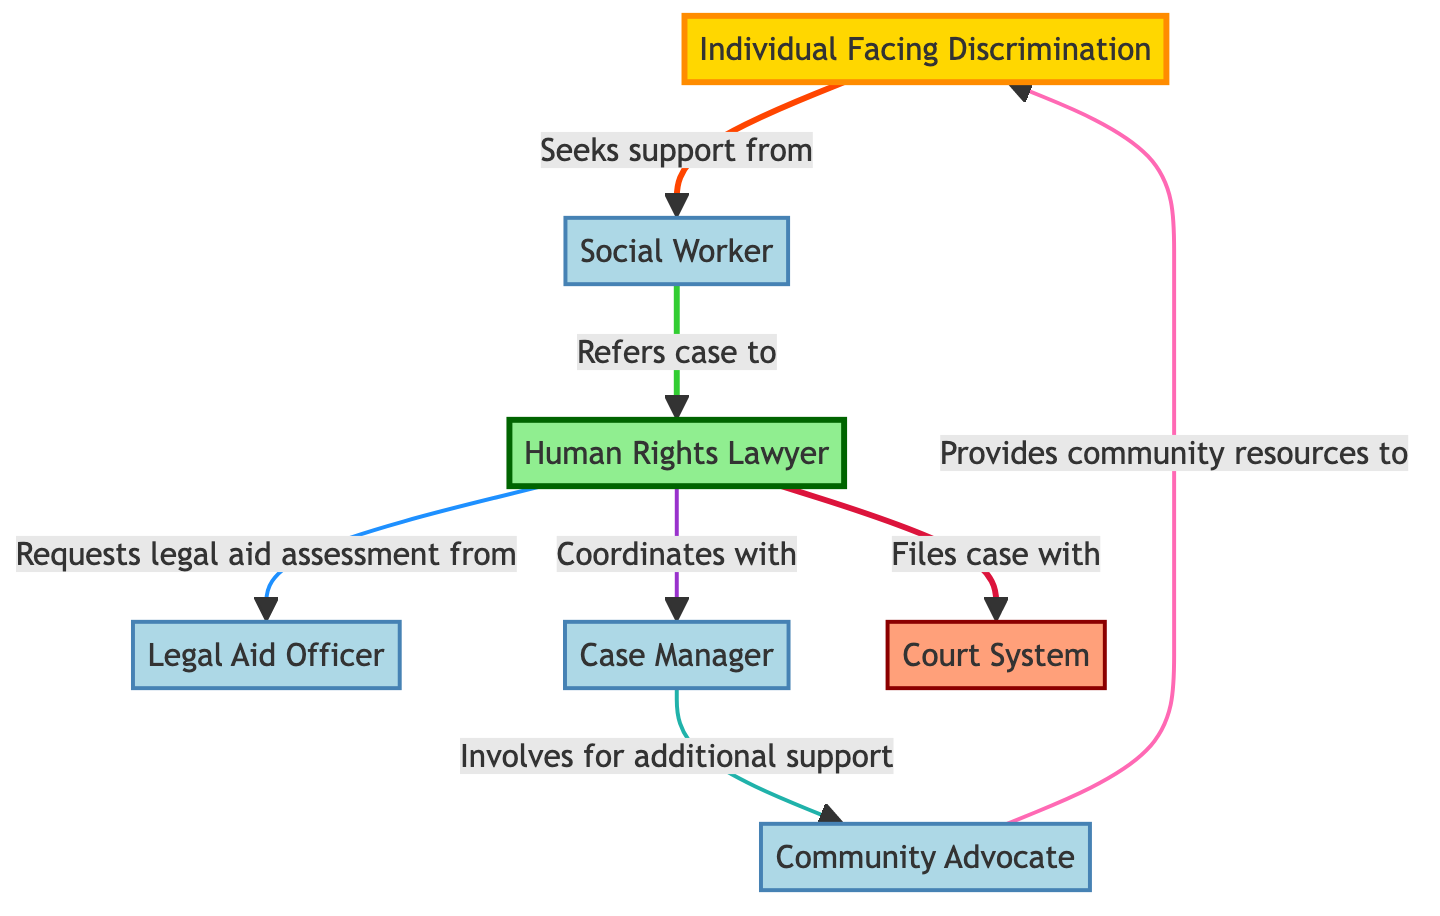What is the role of the Individual Facing Discrimination? The Individual Facing Discrimination seeks support from the Social Worker, indicating their need for assistance handling their discrimination case.
Answer: Seeks support Who does the Social Worker refer the case to? From the diagram, it's clear that the Social Worker directly refers the case to the Human Rights Lawyer.
Answer: Human Rights Lawyer How many support roles are present in the diagram? Counting the roles designated under support, which include Social Worker, Legal Aid Officer, Case Manager, and Community Advocate results in a total of four support roles.
Answer: Four What is the relationship between the Human Rights Lawyer and the Court System? The diagram shows that the Human Rights Lawyer files the case with the Court System, establishing a direct relationship in the legal process.
Answer: Files case Which role coordinates with the Case Manager? The Human Rights Lawyer coordinates with the Case Manager for additional support in managing the case effectively.
Answer: Human Rights Lawyer What does the Community Advocate provide to the Individual Facing Discrimination? The Community Advocate provides community resources, which are critical in supporting the Individual Facing Discrimination in their case.
Answer: Community resources How many connections arise from the Human Rights Lawyer? By reviewing the diagram, it is evident that the Human Rights Lawyer has three outgoing connections: requesting legal aid from the Legal Aid Officer, coordinating with the Case Manager, and filing a case with the Court System.
Answer: Three Which support role involves for additional support? The Case Manager is involved for additional support, indicating their engagement in the case's progression and management.
Answer: Case Manager What is the primary flow of support from the Individual Facing Discrimination to legal representation? The primary flow starts with the Individual Facing Discrimination seeking support from the Social Worker, who then refers the case to the Human Rights Lawyer, demonstrating the pathway to legal representation.
Answer: Social Worker to Human Rights Lawyer 